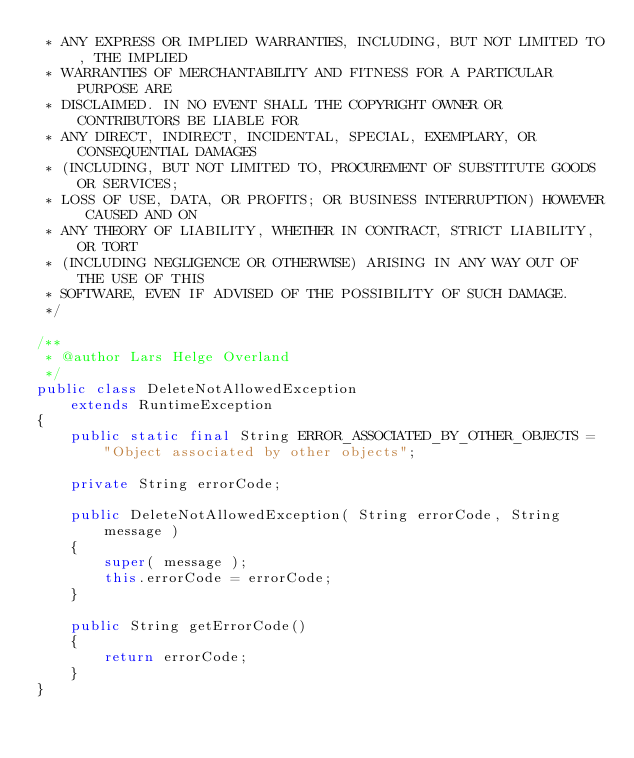<code> <loc_0><loc_0><loc_500><loc_500><_Java_> * ANY EXPRESS OR IMPLIED WARRANTIES, INCLUDING, BUT NOT LIMITED TO, THE IMPLIED
 * WARRANTIES OF MERCHANTABILITY AND FITNESS FOR A PARTICULAR PURPOSE ARE
 * DISCLAIMED. IN NO EVENT SHALL THE COPYRIGHT OWNER OR CONTRIBUTORS BE LIABLE FOR
 * ANY DIRECT, INDIRECT, INCIDENTAL, SPECIAL, EXEMPLARY, OR CONSEQUENTIAL DAMAGES
 * (INCLUDING, BUT NOT LIMITED TO, PROCUREMENT OF SUBSTITUTE GOODS OR SERVICES;
 * LOSS OF USE, DATA, OR PROFITS; OR BUSINESS INTERRUPTION) HOWEVER CAUSED AND ON
 * ANY THEORY OF LIABILITY, WHETHER IN CONTRACT, STRICT LIABILITY, OR TORT
 * (INCLUDING NEGLIGENCE OR OTHERWISE) ARISING IN ANY WAY OUT OF THE USE OF THIS
 * SOFTWARE, EVEN IF ADVISED OF THE POSSIBILITY OF SUCH DAMAGE.
 */

/**
 * @author Lars Helge Overland
 */
public class DeleteNotAllowedException
    extends RuntimeException
{
    public static final String ERROR_ASSOCIATED_BY_OTHER_OBJECTS = "Object associated by other objects";

    private String errorCode;

    public DeleteNotAllowedException( String errorCode, String message )
    {
        super( message );
        this.errorCode = errorCode;
    }

    public String getErrorCode()
    {
        return errorCode;
    }
}
</code> 